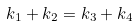<formula> <loc_0><loc_0><loc_500><loc_500>k _ { 1 } + k _ { 2 } = k _ { 3 } + k _ { 4 }</formula> 